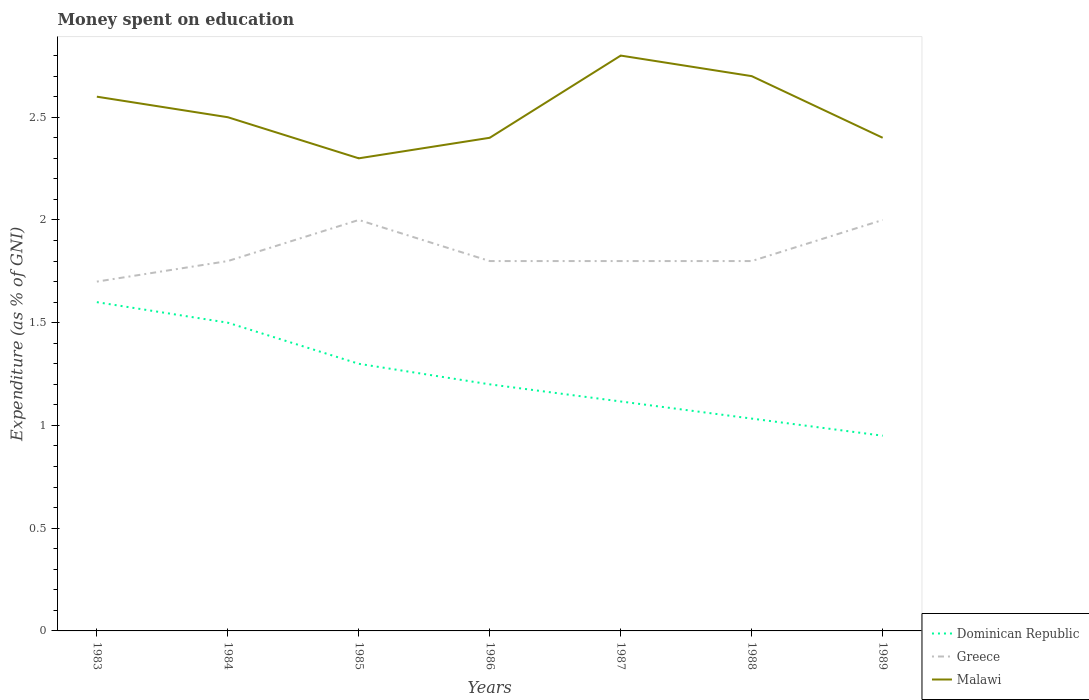How many different coloured lines are there?
Provide a succinct answer. 3. Across all years, what is the maximum amount of money spent on education in Dominican Republic?
Keep it short and to the point. 0.95. What is the total amount of money spent on education in Malawi in the graph?
Provide a short and direct response. 0.3. What is the difference between the highest and the second highest amount of money spent on education in Greece?
Your response must be concise. 0.3. What is the difference between the highest and the lowest amount of money spent on education in Malawi?
Keep it short and to the point. 3. How many lines are there?
Your response must be concise. 3. How many legend labels are there?
Your response must be concise. 3. What is the title of the graph?
Make the answer very short. Money spent on education. What is the label or title of the X-axis?
Make the answer very short. Years. What is the label or title of the Y-axis?
Your answer should be very brief. Expenditure (as % of GNI). What is the Expenditure (as % of GNI) of Dominican Republic in 1983?
Provide a succinct answer. 1.6. What is the Expenditure (as % of GNI) of Greece in 1984?
Your answer should be very brief. 1.8. What is the Expenditure (as % of GNI) in Greece in 1985?
Your answer should be compact. 2. What is the Expenditure (as % of GNI) of Malawi in 1985?
Give a very brief answer. 2.3. What is the Expenditure (as % of GNI) of Malawi in 1986?
Make the answer very short. 2.4. What is the Expenditure (as % of GNI) of Dominican Republic in 1987?
Make the answer very short. 1.12. What is the Expenditure (as % of GNI) in Dominican Republic in 1988?
Your response must be concise. 1.03. What is the Expenditure (as % of GNI) in Malawi in 1988?
Your answer should be compact. 2.7. What is the Expenditure (as % of GNI) of Dominican Republic in 1989?
Make the answer very short. 0.95. What is the Expenditure (as % of GNI) in Greece in 1989?
Offer a very short reply. 2. What is the Expenditure (as % of GNI) in Malawi in 1989?
Your response must be concise. 2.4. Across all years, what is the minimum Expenditure (as % of GNI) of Dominican Republic?
Your response must be concise. 0.95. Across all years, what is the minimum Expenditure (as % of GNI) in Greece?
Provide a short and direct response. 1.7. Across all years, what is the minimum Expenditure (as % of GNI) of Malawi?
Give a very brief answer. 2.3. What is the total Expenditure (as % of GNI) of Dominican Republic in the graph?
Provide a succinct answer. 8.7. What is the difference between the Expenditure (as % of GNI) of Dominican Republic in 1983 and that in 1984?
Keep it short and to the point. 0.1. What is the difference between the Expenditure (as % of GNI) in Greece in 1983 and that in 1984?
Your answer should be compact. -0.1. What is the difference between the Expenditure (as % of GNI) in Dominican Republic in 1983 and that in 1985?
Offer a terse response. 0.3. What is the difference between the Expenditure (as % of GNI) of Greece in 1983 and that in 1986?
Your response must be concise. -0.1. What is the difference between the Expenditure (as % of GNI) of Dominican Republic in 1983 and that in 1987?
Make the answer very short. 0.48. What is the difference between the Expenditure (as % of GNI) of Dominican Republic in 1983 and that in 1988?
Keep it short and to the point. 0.57. What is the difference between the Expenditure (as % of GNI) of Dominican Republic in 1983 and that in 1989?
Keep it short and to the point. 0.65. What is the difference between the Expenditure (as % of GNI) in Greece in 1983 and that in 1989?
Ensure brevity in your answer.  -0.3. What is the difference between the Expenditure (as % of GNI) of Malawi in 1983 and that in 1989?
Ensure brevity in your answer.  0.2. What is the difference between the Expenditure (as % of GNI) in Dominican Republic in 1984 and that in 1987?
Make the answer very short. 0.38. What is the difference between the Expenditure (as % of GNI) in Malawi in 1984 and that in 1987?
Give a very brief answer. -0.3. What is the difference between the Expenditure (as % of GNI) in Dominican Republic in 1984 and that in 1988?
Ensure brevity in your answer.  0.47. What is the difference between the Expenditure (as % of GNI) of Malawi in 1984 and that in 1988?
Make the answer very short. -0.2. What is the difference between the Expenditure (as % of GNI) of Dominican Republic in 1984 and that in 1989?
Provide a short and direct response. 0.55. What is the difference between the Expenditure (as % of GNI) of Malawi in 1984 and that in 1989?
Make the answer very short. 0.1. What is the difference between the Expenditure (as % of GNI) in Malawi in 1985 and that in 1986?
Provide a short and direct response. -0.1. What is the difference between the Expenditure (as % of GNI) in Dominican Republic in 1985 and that in 1987?
Offer a very short reply. 0.18. What is the difference between the Expenditure (as % of GNI) of Greece in 1985 and that in 1987?
Your response must be concise. 0.2. What is the difference between the Expenditure (as % of GNI) of Malawi in 1985 and that in 1987?
Offer a terse response. -0.5. What is the difference between the Expenditure (as % of GNI) in Dominican Republic in 1985 and that in 1988?
Make the answer very short. 0.27. What is the difference between the Expenditure (as % of GNI) in Greece in 1985 and that in 1988?
Keep it short and to the point. 0.2. What is the difference between the Expenditure (as % of GNI) in Malawi in 1985 and that in 1988?
Your response must be concise. -0.4. What is the difference between the Expenditure (as % of GNI) in Dominican Republic in 1985 and that in 1989?
Your answer should be compact. 0.35. What is the difference between the Expenditure (as % of GNI) in Greece in 1985 and that in 1989?
Offer a terse response. 0. What is the difference between the Expenditure (as % of GNI) of Dominican Republic in 1986 and that in 1987?
Offer a very short reply. 0.08. What is the difference between the Expenditure (as % of GNI) in Malawi in 1986 and that in 1987?
Give a very brief answer. -0.4. What is the difference between the Expenditure (as % of GNI) of Malawi in 1986 and that in 1988?
Your answer should be compact. -0.3. What is the difference between the Expenditure (as % of GNI) in Dominican Republic in 1986 and that in 1989?
Provide a succinct answer. 0.25. What is the difference between the Expenditure (as % of GNI) in Malawi in 1986 and that in 1989?
Your answer should be very brief. 0. What is the difference between the Expenditure (as % of GNI) in Dominican Republic in 1987 and that in 1988?
Make the answer very short. 0.08. What is the difference between the Expenditure (as % of GNI) in Malawi in 1987 and that in 1988?
Your response must be concise. 0.1. What is the difference between the Expenditure (as % of GNI) in Dominican Republic in 1987 and that in 1989?
Provide a short and direct response. 0.17. What is the difference between the Expenditure (as % of GNI) of Malawi in 1987 and that in 1989?
Ensure brevity in your answer.  0.4. What is the difference between the Expenditure (as % of GNI) of Dominican Republic in 1988 and that in 1989?
Give a very brief answer. 0.08. What is the difference between the Expenditure (as % of GNI) of Dominican Republic in 1983 and the Expenditure (as % of GNI) of Malawi in 1984?
Provide a succinct answer. -0.9. What is the difference between the Expenditure (as % of GNI) of Dominican Republic in 1983 and the Expenditure (as % of GNI) of Greece in 1985?
Offer a very short reply. -0.4. What is the difference between the Expenditure (as % of GNI) in Greece in 1983 and the Expenditure (as % of GNI) in Malawi in 1985?
Offer a terse response. -0.6. What is the difference between the Expenditure (as % of GNI) in Dominican Republic in 1983 and the Expenditure (as % of GNI) in Greece in 1986?
Your answer should be compact. -0.2. What is the difference between the Expenditure (as % of GNI) in Dominican Republic in 1983 and the Expenditure (as % of GNI) in Malawi in 1986?
Your answer should be very brief. -0.8. What is the difference between the Expenditure (as % of GNI) of Dominican Republic in 1983 and the Expenditure (as % of GNI) of Greece in 1987?
Offer a terse response. -0.2. What is the difference between the Expenditure (as % of GNI) of Dominican Republic in 1983 and the Expenditure (as % of GNI) of Malawi in 1987?
Your answer should be compact. -1.2. What is the difference between the Expenditure (as % of GNI) of Dominican Republic in 1983 and the Expenditure (as % of GNI) of Greece in 1988?
Give a very brief answer. -0.2. What is the difference between the Expenditure (as % of GNI) in Dominican Republic in 1983 and the Expenditure (as % of GNI) in Malawi in 1988?
Offer a terse response. -1.1. What is the difference between the Expenditure (as % of GNI) in Greece in 1983 and the Expenditure (as % of GNI) in Malawi in 1988?
Provide a succinct answer. -1. What is the difference between the Expenditure (as % of GNI) in Greece in 1983 and the Expenditure (as % of GNI) in Malawi in 1989?
Your answer should be compact. -0.7. What is the difference between the Expenditure (as % of GNI) of Dominican Republic in 1984 and the Expenditure (as % of GNI) of Greece in 1985?
Ensure brevity in your answer.  -0.5. What is the difference between the Expenditure (as % of GNI) in Dominican Republic in 1984 and the Expenditure (as % of GNI) in Malawi in 1985?
Keep it short and to the point. -0.8. What is the difference between the Expenditure (as % of GNI) in Greece in 1984 and the Expenditure (as % of GNI) in Malawi in 1985?
Provide a short and direct response. -0.5. What is the difference between the Expenditure (as % of GNI) in Dominican Republic in 1984 and the Expenditure (as % of GNI) in Greece in 1986?
Your answer should be compact. -0.3. What is the difference between the Expenditure (as % of GNI) of Dominican Republic in 1984 and the Expenditure (as % of GNI) of Malawi in 1986?
Keep it short and to the point. -0.9. What is the difference between the Expenditure (as % of GNI) of Dominican Republic in 1984 and the Expenditure (as % of GNI) of Malawi in 1987?
Give a very brief answer. -1.3. What is the difference between the Expenditure (as % of GNI) in Greece in 1984 and the Expenditure (as % of GNI) in Malawi in 1987?
Provide a succinct answer. -1. What is the difference between the Expenditure (as % of GNI) of Dominican Republic in 1984 and the Expenditure (as % of GNI) of Malawi in 1988?
Your answer should be compact. -1.2. What is the difference between the Expenditure (as % of GNI) in Dominican Republic in 1985 and the Expenditure (as % of GNI) in Greece in 1986?
Offer a terse response. -0.5. What is the difference between the Expenditure (as % of GNI) of Dominican Republic in 1985 and the Expenditure (as % of GNI) of Malawi in 1986?
Your response must be concise. -1.1. What is the difference between the Expenditure (as % of GNI) of Greece in 1985 and the Expenditure (as % of GNI) of Malawi in 1986?
Provide a succinct answer. -0.4. What is the difference between the Expenditure (as % of GNI) of Dominican Republic in 1985 and the Expenditure (as % of GNI) of Malawi in 1987?
Your response must be concise. -1.5. What is the difference between the Expenditure (as % of GNI) of Dominican Republic in 1985 and the Expenditure (as % of GNI) of Malawi in 1988?
Your answer should be compact. -1.4. What is the difference between the Expenditure (as % of GNI) of Dominican Republic in 1985 and the Expenditure (as % of GNI) of Greece in 1989?
Keep it short and to the point. -0.7. What is the difference between the Expenditure (as % of GNI) of Dominican Republic in 1986 and the Expenditure (as % of GNI) of Malawi in 1987?
Provide a succinct answer. -1.6. What is the difference between the Expenditure (as % of GNI) of Dominican Republic in 1986 and the Expenditure (as % of GNI) of Greece in 1988?
Provide a short and direct response. -0.6. What is the difference between the Expenditure (as % of GNI) in Dominican Republic in 1986 and the Expenditure (as % of GNI) in Malawi in 1988?
Provide a short and direct response. -1.5. What is the difference between the Expenditure (as % of GNI) of Greece in 1986 and the Expenditure (as % of GNI) of Malawi in 1988?
Provide a short and direct response. -0.9. What is the difference between the Expenditure (as % of GNI) in Dominican Republic in 1986 and the Expenditure (as % of GNI) in Malawi in 1989?
Your answer should be very brief. -1.2. What is the difference between the Expenditure (as % of GNI) of Greece in 1986 and the Expenditure (as % of GNI) of Malawi in 1989?
Ensure brevity in your answer.  -0.6. What is the difference between the Expenditure (as % of GNI) in Dominican Republic in 1987 and the Expenditure (as % of GNI) in Greece in 1988?
Offer a very short reply. -0.68. What is the difference between the Expenditure (as % of GNI) of Dominican Republic in 1987 and the Expenditure (as % of GNI) of Malawi in 1988?
Your response must be concise. -1.58. What is the difference between the Expenditure (as % of GNI) of Greece in 1987 and the Expenditure (as % of GNI) of Malawi in 1988?
Provide a succinct answer. -0.9. What is the difference between the Expenditure (as % of GNI) in Dominican Republic in 1987 and the Expenditure (as % of GNI) in Greece in 1989?
Keep it short and to the point. -0.88. What is the difference between the Expenditure (as % of GNI) in Dominican Republic in 1987 and the Expenditure (as % of GNI) in Malawi in 1989?
Provide a succinct answer. -1.28. What is the difference between the Expenditure (as % of GNI) in Dominican Republic in 1988 and the Expenditure (as % of GNI) in Greece in 1989?
Your answer should be compact. -0.97. What is the difference between the Expenditure (as % of GNI) in Dominican Republic in 1988 and the Expenditure (as % of GNI) in Malawi in 1989?
Ensure brevity in your answer.  -1.37. What is the average Expenditure (as % of GNI) in Dominican Republic per year?
Offer a very short reply. 1.24. What is the average Expenditure (as % of GNI) in Greece per year?
Your response must be concise. 1.84. What is the average Expenditure (as % of GNI) of Malawi per year?
Ensure brevity in your answer.  2.53. In the year 1983, what is the difference between the Expenditure (as % of GNI) in Greece and Expenditure (as % of GNI) in Malawi?
Your answer should be very brief. -0.9. In the year 1984, what is the difference between the Expenditure (as % of GNI) of Greece and Expenditure (as % of GNI) of Malawi?
Make the answer very short. -0.7. In the year 1985, what is the difference between the Expenditure (as % of GNI) of Dominican Republic and Expenditure (as % of GNI) of Malawi?
Make the answer very short. -1. In the year 1986, what is the difference between the Expenditure (as % of GNI) in Greece and Expenditure (as % of GNI) in Malawi?
Ensure brevity in your answer.  -0.6. In the year 1987, what is the difference between the Expenditure (as % of GNI) of Dominican Republic and Expenditure (as % of GNI) of Greece?
Give a very brief answer. -0.68. In the year 1987, what is the difference between the Expenditure (as % of GNI) of Dominican Republic and Expenditure (as % of GNI) of Malawi?
Provide a short and direct response. -1.68. In the year 1987, what is the difference between the Expenditure (as % of GNI) of Greece and Expenditure (as % of GNI) of Malawi?
Make the answer very short. -1. In the year 1988, what is the difference between the Expenditure (as % of GNI) in Dominican Republic and Expenditure (as % of GNI) in Greece?
Your answer should be very brief. -0.77. In the year 1988, what is the difference between the Expenditure (as % of GNI) of Dominican Republic and Expenditure (as % of GNI) of Malawi?
Provide a short and direct response. -1.67. In the year 1988, what is the difference between the Expenditure (as % of GNI) in Greece and Expenditure (as % of GNI) in Malawi?
Provide a succinct answer. -0.9. In the year 1989, what is the difference between the Expenditure (as % of GNI) of Dominican Republic and Expenditure (as % of GNI) of Greece?
Your answer should be compact. -1.05. In the year 1989, what is the difference between the Expenditure (as % of GNI) in Dominican Republic and Expenditure (as % of GNI) in Malawi?
Ensure brevity in your answer.  -1.45. In the year 1989, what is the difference between the Expenditure (as % of GNI) of Greece and Expenditure (as % of GNI) of Malawi?
Offer a terse response. -0.4. What is the ratio of the Expenditure (as % of GNI) in Dominican Republic in 1983 to that in 1984?
Provide a succinct answer. 1.07. What is the ratio of the Expenditure (as % of GNI) of Greece in 1983 to that in 1984?
Your response must be concise. 0.94. What is the ratio of the Expenditure (as % of GNI) of Malawi in 1983 to that in 1984?
Your answer should be very brief. 1.04. What is the ratio of the Expenditure (as % of GNI) of Dominican Republic in 1983 to that in 1985?
Your response must be concise. 1.23. What is the ratio of the Expenditure (as % of GNI) in Malawi in 1983 to that in 1985?
Offer a very short reply. 1.13. What is the ratio of the Expenditure (as % of GNI) in Dominican Republic in 1983 to that in 1986?
Your answer should be compact. 1.33. What is the ratio of the Expenditure (as % of GNI) of Greece in 1983 to that in 1986?
Your answer should be compact. 0.94. What is the ratio of the Expenditure (as % of GNI) of Dominican Republic in 1983 to that in 1987?
Ensure brevity in your answer.  1.43. What is the ratio of the Expenditure (as % of GNI) in Greece in 1983 to that in 1987?
Your answer should be very brief. 0.94. What is the ratio of the Expenditure (as % of GNI) in Dominican Republic in 1983 to that in 1988?
Your answer should be very brief. 1.55. What is the ratio of the Expenditure (as % of GNI) of Greece in 1983 to that in 1988?
Ensure brevity in your answer.  0.94. What is the ratio of the Expenditure (as % of GNI) in Malawi in 1983 to that in 1988?
Offer a very short reply. 0.96. What is the ratio of the Expenditure (as % of GNI) in Dominican Republic in 1983 to that in 1989?
Your answer should be very brief. 1.68. What is the ratio of the Expenditure (as % of GNI) of Greece in 1983 to that in 1989?
Offer a terse response. 0.85. What is the ratio of the Expenditure (as % of GNI) in Dominican Republic in 1984 to that in 1985?
Make the answer very short. 1.15. What is the ratio of the Expenditure (as % of GNI) of Greece in 1984 to that in 1985?
Keep it short and to the point. 0.9. What is the ratio of the Expenditure (as % of GNI) of Malawi in 1984 to that in 1985?
Provide a succinct answer. 1.09. What is the ratio of the Expenditure (as % of GNI) of Malawi in 1984 to that in 1986?
Give a very brief answer. 1.04. What is the ratio of the Expenditure (as % of GNI) of Dominican Republic in 1984 to that in 1987?
Offer a very short reply. 1.34. What is the ratio of the Expenditure (as % of GNI) in Malawi in 1984 to that in 1987?
Keep it short and to the point. 0.89. What is the ratio of the Expenditure (as % of GNI) of Dominican Republic in 1984 to that in 1988?
Offer a very short reply. 1.45. What is the ratio of the Expenditure (as % of GNI) of Greece in 1984 to that in 1988?
Your response must be concise. 1. What is the ratio of the Expenditure (as % of GNI) in Malawi in 1984 to that in 1988?
Your answer should be very brief. 0.93. What is the ratio of the Expenditure (as % of GNI) in Dominican Republic in 1984 to that in 1989?
Offer a very short reply. 1.58. What is the ratio of the Expenditure (as % of GNI) of Greece in 1984 to that in 1989?
Your response must be concise. 0.9. What is the ratio of the Expenditure (as % of GNI) in Malawi in 1984 to that in 1989?
Give a very brief answer. 1.04. What is the ratio of the Expenditure (as % of GNI) of Greece in 1985 to that in 1986?
Your answer should be compact. 1.11. What is the ratio of the Expenditure (as % of GNI) in Dominican Republic in 1985 to that in 1987?
Your answer should be very brief. 1.16. What is the ratio of the Expenditure (as % of GNI) in Malawi in 1985 to that in 1987?
Ensure brevity in your answer.  0.82. What is the ratio of the Expenditure (as % of GNI) of Dominican Republic in 1985 to that in 1988?
Give a very brief answer. 1.26. What is the ratio of the Expenditure (as % of GNI) of Greece in 1985 to that in 1988?
Your answer should be compact. 1.11. What is the ratio of the Expenditure (as % of GNI) in Malawi in 1985 to that in 1988?
Your answer should be compact. 0.85. What is the ratio of the Expenditure (as % of GNI) in Dominican Republic in 1985 to that in 1989?
Give a very brief answer. 1.37. What is the ratio of the Expenditure (as % of GNI) of Greece in 1985 to that in 1989?
Your response must be concise. 1. What is the ratio of the Expenditure (as % of GNI) of Malawi in 1985 to that in 1989?
Keep it short and to the point. 0.96. What is the ratio of the Expenditure (as % of GNI) in Dominican Republic in 1986 to that in 1987?
Your response must be concise. 1.07. What is the ratio of the Expenditure (as % of GNI) in Greece in 1986 to that in 1987?
Offer a terse response. 1. What is the ratio of the Expenditure (as % of GNI) of Malawi in 1986 to that in 1987?
Your answer should be compact. 0.86. What is the ratio of the Expenditure (as % of GNI) of Dominican Republic in 1986 to that in 1988?
Your response must be concise. 1.16. What is the ratio of the Expenditure (as % of GNI) in Greece in 1986 to that in 1988?
Make the answer very short. 1. What is the ratio of the Expenditure (as % of GNI) of Malawi in 1986 to that in 1988?
Keep it short and to the point. 0.89. What is the ratio of the Expenditure (as % of GNI) in Dominican Republic in 1986 to that in 1989?
Make the answer very short. 1.26. What is the ratio of the Expenditure (as % of GNI) of Malawi in 1986 to that in 1989?
Your response must be concise. 1. What is the ratio of the Expenditure (as % of GNI) in Dominican Republic in 1987 to that in 1988?
Offer a terse response. 1.08. What is the ratio of the Expenditure (as % of GNI) in Dominican Republic in 1987 to that in 1989?
Keep it short and to the point. 1.18. What is the ratio of the Expenditure (as % of GNI) of Greece in 1987 to that in 1989?
Provide a succinct answer. 0.9. What is the ratio of the Expenditure (as % of GNI) of Malawi in 1987 to that in 1989?
Keep it short and to the point. 1.17. What is the ratio of the Expenditure (as % of GNI) in Dominican Republic in 1988 to that in 1989?
Your response must be concise. 1.09. What is the difference between the highest and the second highest Expenditure (as % of GNI) in Malawi?
Your answer should be compact. 0.1. What is the difference between the highest and the lowest Expenditure (as % of GNI) in Dominican Republic?
Your response must be concise. 0.65. 